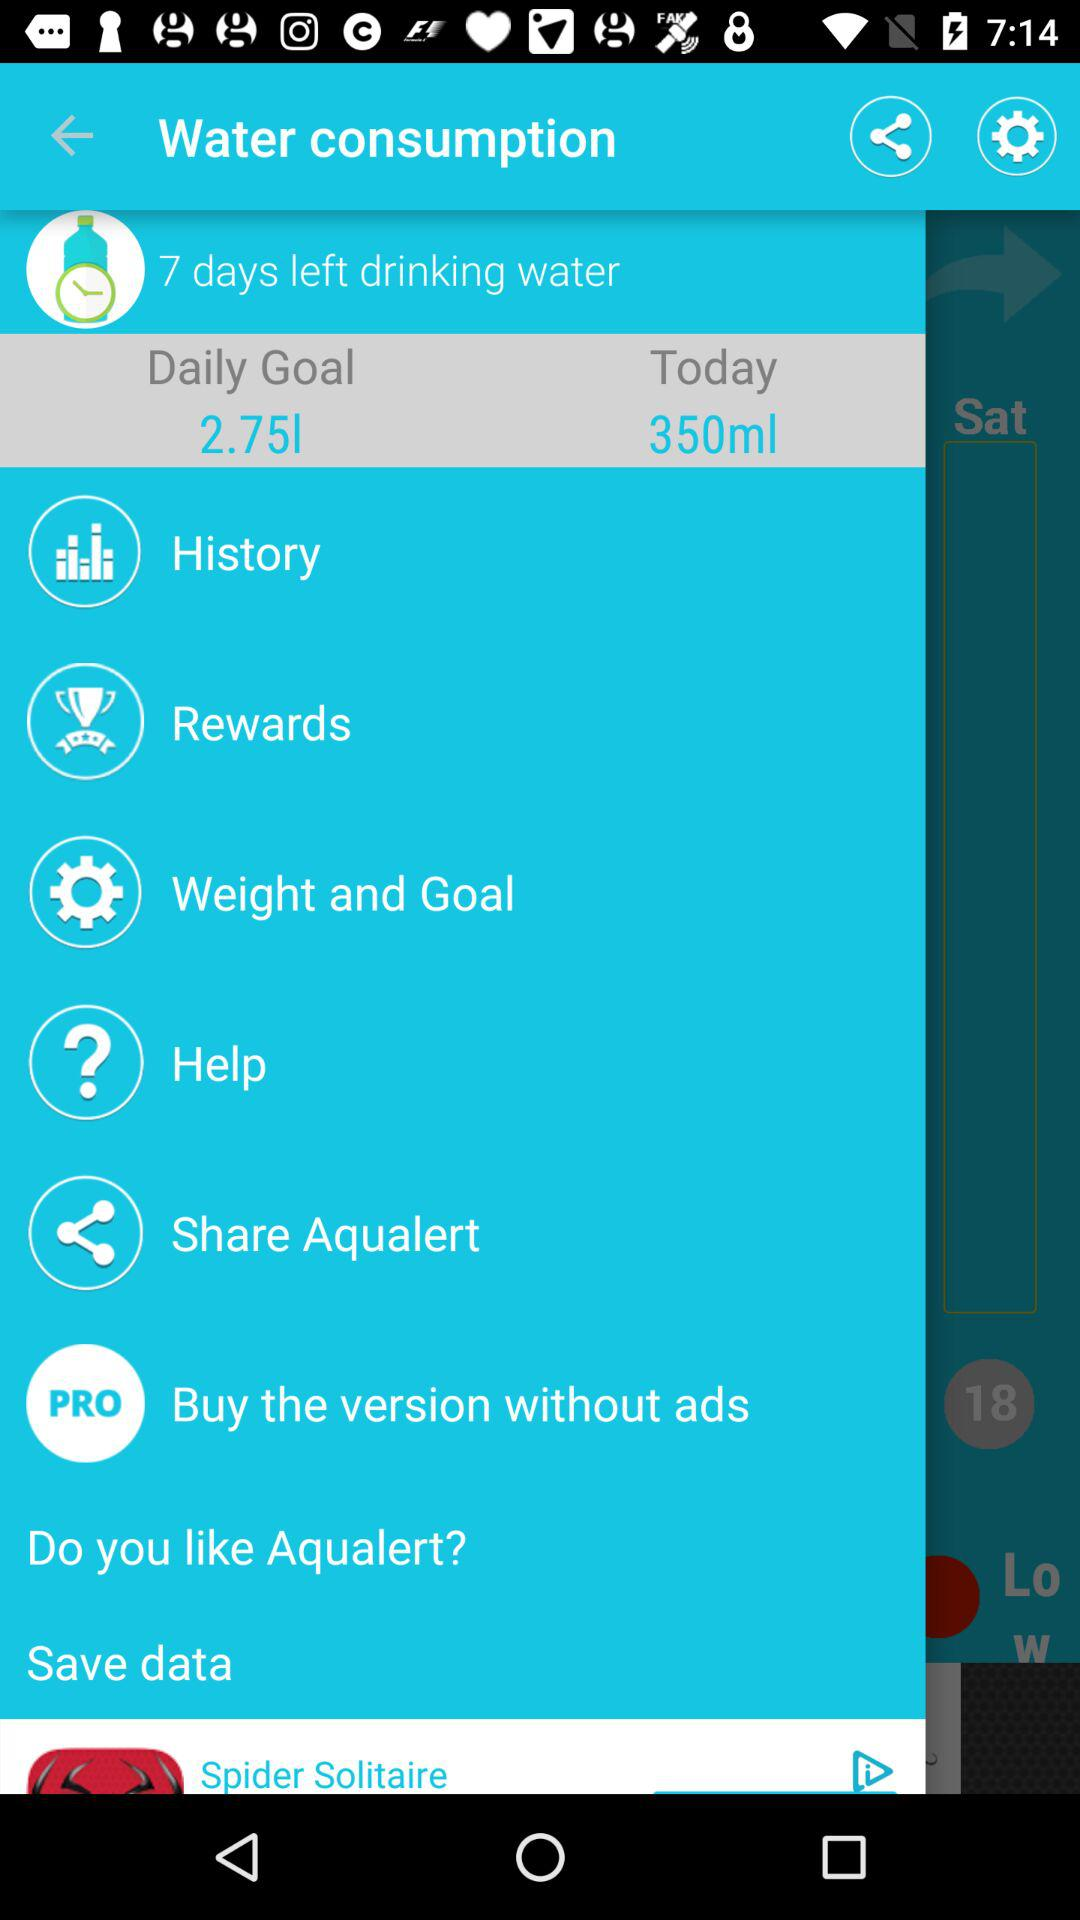What is the daily goal? The daily goal is 2.75 liters. 